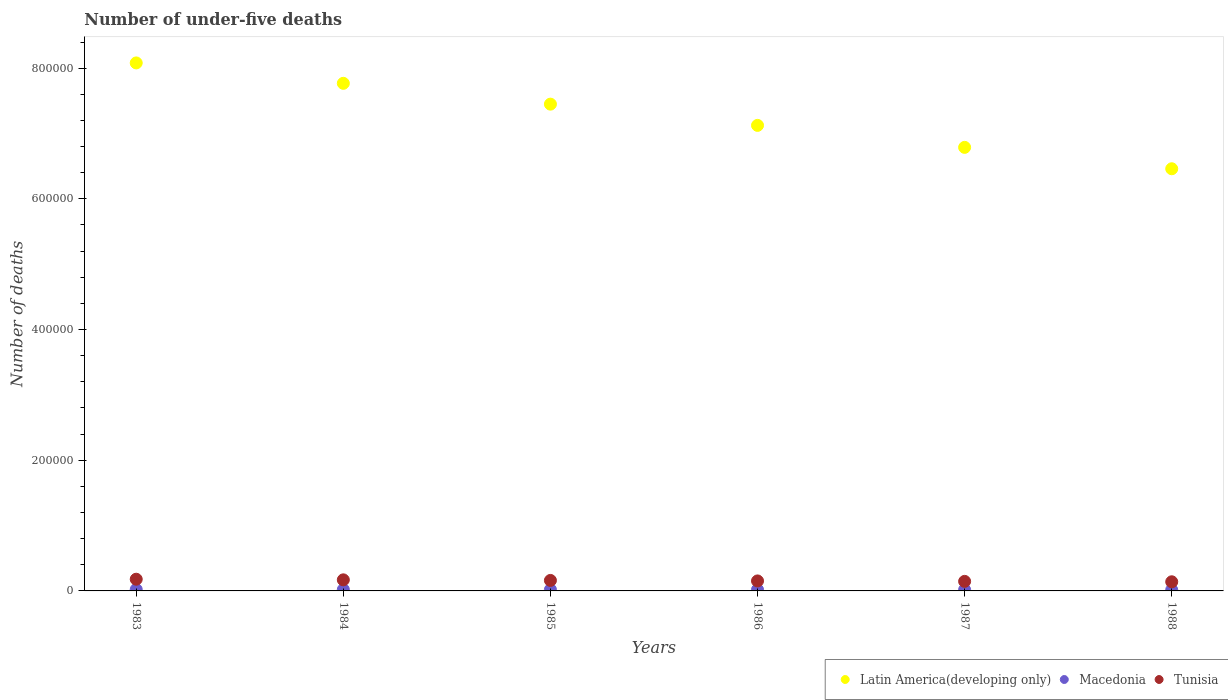Is the number of dotlines equal to the number of legend labels?
Ensure brevity in your answer.  Yes. What is the number of under-five deaths in Latin America(developing only) in 1988?
Offer a very short reply. 6.46e+05. Across all years, what is the maximum number of under-five deaths in Tunisia?
Offer a very short reply. 1.79e+04. Across all years, what is the minimum number of under-five deaths in Latin America(developing only)?
Offer a terse response. 6.46e+05. In which year was the number of under-five deaths in Macedonia maximum?
Your answer should be compact. 1983. What is the total number of under-five deaths in Tunisia in the graph?
Ensure brevity in your answer.  9.48e+04. What is the difference between the number of under-five deaths in Tunisia in 1984 and that in 1988?
Provide a short and direct response. 2978. What is the difference between the number of under-five deaths in Latin America(developing only) in 1984 and the number of under-five deaths in Macedonia in 1988?
Ensure brevity in your answer.  7.75e+05. What is the average number of under-five deaths in Tunisia per year?
Give a very brief answer. 1.58e+04. In the year 1986, what is the difference between the number of under-five deaths in Latin America(developing only) and number of under-five deaths in Macedonia?
Offer a very short reply. 7.11e+05. In how many years, is the number of under-five deaths in Latin America(developing only) greater than 160000?
Make the answer very short. 6. What is the ratio of the number of under-five deaths in Tunisia in 1984 to that in 1987?
Provide a succinct answer. 1.16. What is the difference between the highest and the second highest number of under-five deaths in Latin America(developing only)?
Offer a terse response. 3.12e+04. What is the difference between the highest and the lowest number of under-five deaths in Tunisia?
Offer a very short reply. 3932. Is the sum of the number of under-five deaths in Latin America(developing only) in 1984 and 1988 greater than the maximum number of under-five deaths in Tunisia across all years?
Keep it short and to the point. Yes. Is the number of under-five deaths in Macedonia strictly greater than the number of under-five deaths in Tunisia over the years?
Give a very brief answer. No. How many dotlines are there?
Offer a terse response. 3. How are the legend labels stacked?
Ensure brevity in your answer.  Horizontal. What is the title of the graph?
Make the answer very short. Number of under-five deaths. What is the label or title of the Y-axis?
Offer a very short reply. Number of deaths. What is the Number of deaths of Latin America(developing only) in 1983?
Provide a short and direct response. 8.08e+05. What is the Number of deaths in Macedonia in 1983?
Keep it short and to the point. 2202. What is the Number of deaths of Tunisia in 1983?
Keep it short and to the point. 1.79e+04. What is the Number of deaths of Latin America(developing only) in 1984?
Offer a terse response. 7.77e+05. What is the Number of deaths in Macedonia in 1984?
Your answer should be very brief. 2082. What is the Number of deaths in Tunisia in 1984?
Your answer should be very brief. 1.70e+04. What is the Number of deaths in Latin America(developing only) in 1985?
Ensure brevity in your answer.  7.45e+05. What is the Number of deaths in Macedonia in 1985?
Offer a terse response. 1992. What is the Number of deaths of Tunisia in 1985?
Your answer should be compact. 1.61e+04. What is the Number of deaths in Latin America(developing only) in 1986?
Offer a very short reply. 7.12e+05. What is the Number of deaths of Macedonia in 1986?
Your answer should be compact. 1920. What is the Number of deaths in Tunisia in 1986?
Your answer should be compact. 1.53e+04. What is the Number of deaths of Latin America(developing only) in 1987?
Offer a very short reply. 6.79e+05. What is the Number of deaths in Macedonia in 1987?
Your answer should be very brief. 1805. What is the Number of deaths of Tunisia in 1987?
Provide a succinct answer. 1.46e+04. What is the Number of deaths of Latin America(developing only) in 1988?
Your response must be concise. 6.46e+05. What is the Number of deaths of Macedonia in 1988?
Your response must be concise. 1615. What is the Number of deaths of Tunisia in 1988?
Give a very brief answer. 1.40e+04. Across all years, what is the maximum Number of deaths in Latin America(developing only)?
Provide a short and direct response. 8.08e+05. Across all years, what is the maximum Number of deaths in Macedonia?
Give a very brief answer. 2202. Across all years, what is the maximum Number of deaths of Tunisia?
Ensure brevity in your answer.  1.79e+04. Across all years, what is the minimum Number of deaths of Latin America(developing only)?
Ensure brevity in your answer.  6.46e+05. Across all years, what is the minimum Number of deaths of Macedonia?
Your response must be concise. 1615. Across all years, what is the minimum Number of deaths of Tunisia?
Make the answer very short. 1.40e+04. What is the total Number of deaths of Latin America(developing only) in the graph?
Your answer should be compact. 4.37e+06. What is the total Number of deaths in Macedonia in the graph?
Offer a very short reply. 1.16e+04. What is the total Number of deaths of Tunisia in the graph?
Offer a very short reply. 9.48e+04. What is the difference between the Number of deaths of Latin America(developing only) in 1983 and that in 1984?
Offer a terse response. 3.12e+04. What is the difference between the Number of deaths in Macedonia in 1983 and that in 1984?
Provide a short and direct response. 120. What is the difference between the Number of deaths in Tunisia in 1983 and that in 1984?
Provide a short and direct response. 954. What is the difference between the Number of deaths of Latin America(developing only) in 1983 and that in 1985?
Make the answer very short. 6.31e+04. What is the difference between the Number of deaths in Macedonia in 1983 and that in 1985?
Your answer should be compact. 210. What is the difference between the Number of deaths of Tunisia in 1983 and that in 1985?
Your answer should be very brief. 1849. What is the difference between the Number of deaths of Latin America(developing only) in 1983 and that in 1986?
Your answer should be very brief. 9.56e+04. What is the difference between the Number of deaths of Macedonia in 1983 and that in 1986?
Provide a short and direct response. 282. What is the difference between the Number of deaths in Tunisia in 1983 and that in 1986?
Ensure brevity in your answer.  2610. What is the difference between the Number of deaths of Latin America(developing only) in 1983 and that in 1987?
Keep it short and to the point. 1.29e+05. What is the difference between the Number of deaths in Macedonia in 1983 and that in 1987?
Provide a succinct answer. 397. What is the difference between the Number of deaths in Tunisia in 1983 and that in 1987?
Your response must be concise. 3296. What is the difference between the Number of deaths of Latin America(developing only) in 1983 and that in 1988?
Keep it short and to the point. 1.62e+05. What is the difference between the Number of deaths of Macedonia in 1983 and that in 1988?
Keep it short and to the point. 587. What is the difference between the Number of deaths in Tunisia in 1983 and that in 1988?
Offer a very short reply. 3932. What is the difference between the Number of deaths in Latin America(developing only) in 1984 and that in 1985?
Make the answer very short. 3.19e+04. What is the difference between the Number of deaths in Tunisia in 1984 and that in 1985?
Keep it short and to the point. 895. What is the difference between the Number of deaths of Latin America(developing only) in 1984 and that in 1986?
Provide a short and direct response. 6.44e+04. What is the difference between the Number of deaths of Macedonia in 1984 and that in 1986?
Your answer should be very brief. 162. What is the difference between the Number of deaths in Tunisia in 1984 and that in 1986?
Provide a short and direct response. 1656. What is the difference between the Number of deaths of Latin America(developing only) in 1984 and that in 1987?
Give a very brief answer. 9.80e+04. What is the difference between the Number of deaths in Macedonia in 1984 and that in 1987?
Give a very brief answer. 277. What is the difference between the Number of deaths in Tunisia in 1984 and that in 1987?
Provide a short and direct response. 2342. What is the difference between the Number of deaths of Latin America(developing only) in 1984 and that in 1988?
Offer a very short reply. 1.31e+05. What is the difference between the Number of deaths in Macedonia in 1984 and that in 1988?
Give a very brief answer. 467. What is the difference between the Number of deaths of Tunisia in 1984 and that in 1988?
Provide a succinct answer. 2978. What is the difference between the Number of deaths in Latin America(developing only) in 1985 and that in 1986?
Provide a succinct answer. 3.25e+04. What is the difference between the Number of deaths of Tunisia in 1985 and that in 1986?
Offer a terse response. 761. What is the difference between the Number of deaths in Latin America(developing only) in 1985 and that in 1987?
Make the answer very short. 6.62e+04. What is the difference between the Number of deaths of Macedonia in 1985 and that in 1987?
Your response must be concise. 187. What is the difference between the Number of deaths in Tunisia in 1985 and that in 1987?
Your answer should be compact. 1447. What is the difference between the Number of deaths in Latin America(developing only) in 1985 and that in 1988?
Keep it short and to the point. 9.89e+04. What is the difference between the Number of deaths of Macedonia in 1985 and that in 1988?
Your answer should be very brief. 377. What is the difference between the Number of deaths of Tunisia in 1985 and that in 1988?
Give a very brief answer. 2083. What is the difference between the Number of deaths in Latin America(developing only) in 1986 and that in 1987?
Ensure brevity in your answer.  3.37e+04. What is the difference between the Number of deaths in Macedonia in 1986 and that in 1987?
Give a very brief answer. 115. What is the difference between the Number of deaths in Tunisia in 1986 and that in 1987?
Your answer should be compact. 686. What is the difference between the Number of deaths in Latin America(developing only) in 1986 and that in 1988?
Keep it short and to the point. 6.64e+04. What is the difference between the Number of deaths in Macedonia in 1986 and that in 1988?
Offer a terse response. 305. What is the difference between the Number of deaths in Tunisia in 1986 and that in 1988?
Provide a short and direct response. 1322. What is the difference between the Number of deaths in Latin America(developing only) in 1987 and that in 1988?
Give a very brief answer. 3.27e+04. What is the difference between the Number of deaths of Macedonia in 1987 and that in 1988?
Your response must be concise. 190. What is the difference between the Number of deaths of Tunisia in 1987 and that in 1988?
Make the answer very short. 636. What is the difference between the Number of deaths of Latin America(developing only) in 1983 and the Number of deaths of Macedonia in 1984?
Give a very brief answer. 8.06e+05. What is the difference between the Number of deaths in Latin America(developing only) in 1983 and the Number of deaths in Tunisia in 1984?
Your answer should be very brief. 7.91e+05. What is the difference between the Number of deaths in Macedonia in 1983 and the Number of deaths in Tunisia in 1984?
Provide a short and direct response. -1.48e+04. What is the difference between the Number of deaths in Latin America(developing only) in 1983 and the Number of deaths in Macedonia in 1985?
Provide a succinct answer. 8.06e+05. What is the difference between the Number of deaths of Latin America(developing only) in 1983 and the Number of deaths of Tunisia in 1985?
Your response must be concise. 7.92e+05. What is the difference between the Number of deaths in Macedonia in 1983 and the Number of deaths in Tunisia in 1985?
Offer a very short reply. -1.39e+04. What is the difference between the Number of deaths in Latin America(developing only) in 1983 and the Number of deaths in Macedonia in 1986?
Your response must be concise. 8.06e+05. What is the difference between the Number of deaths of Latin America(developing only) in 1983 and the Number of deaths of Tunisia in 1986?
Give a very brief answer. 7.93e+05. What is the difference between the Number of deaths of Macedonia in 1983 and the Number of deaths of Tunisia in 1986?
Offer a very short reply. -1.31e+04. What is the difference between the Number of deaths in Latin America(developing only) in 1983 and the Number of deaths in Macedonia in 1987?
Offer a very short reply. 8.06e+05. What is the difference between the Number of deaths in Latin America(developing only) in 1983 and the Number of deaths in Tunisia in 1987?
Give a very brief answer. 7.93e+05. What is the difference between the Number of deaths of Macedonia in 1983 and the Number of deaths of Tunisia in 1987?
Your answer should be compact. -1.24e+04. What is the difference between the Number of deaths of Latin America(developing only) in 1983 and the Number of deaths of Macedonia in 1988?
Provide a succinct answer. 8.06e+05. What is the difference between the Number of deaths in Latin America(developing only) in 1983 and the Number of deaths in Tunisia in 1988?
Provide a succinct answer. 7.94e+05. What is the difference between the Number of deaths in Macedonia in 1983 and the Number of deaths in Tunisia in 1988?
Your response must be concise. -1.18e+04. What is the difference between the Number of deaths of Latin America(developing only) in 1984 and the Number of deaths of Macedonia in 1985?
Your answer should be very brief. 7.75e+05. What is the difference between the Number of deaths of Latin America(developing only) in 1984 and the Number of deaths of Tunisia in 1985?
Your response must be concise. 7.61e+05. What is the difference between the Number of deaths of Macedonia in 1984 and the Number of deaths of Tunisia in 1985?
Ensure brevity in your answer.  -1.40e+04. What is the difference between the Number of deaths in Latin America(developing only) in 1984 and the Number of deaths in Macedonia in 1986?
Your answer should be very brief. 7.75e+05. What is the difference between the Number of deaths of Latin America(developing only) in 1984 and the Number of deaths of Tunisia in 1986?
Provide a succinct answer. 7.62e+05. What is the difference between the Number of deaths in Macedonia in 1984 and the Number of deaths in Tunisia in 1986?
Provide a short and direct response. -1.32e+04. What is the difference between the Number of deaths in Latin America(developing only) in 1984 and the Number of deaths in Macedonia in 1987?
Keep it short and to the point. 7.75e+05. What is the difference between the Number of deaths of Latin America(developing only) in 1984 and the Number of deaths of Tunisia in 1987?
Your answer should be compact. 7.62e+05. What is the difference between the Number of deaths of Macedonia in 1984 and the Number of deaths of Tunisia in 1987?
Provide a short and direct response. -1.25e+04. What is the difference between the Number of deaths in Latin America(developing only) in 1984 and the Number of deaths in Macedonia in 1988?
Make the answer very short. 7.75e+05. What is the difference between the Number of deaths in Latin America(developing only) in 1984 and the Number of deaths in Tunisia in 1988?
Provide a short and direct response. 7.63e+05. What is the difference between the Number of deaths of Macedonia in 1984 and the Number of deaths of Tunisia in 1988?
Ensure brevity in your answer.  -1.19e+04. What is the difference between the Number of deaths of Latin America(developing only) in 1985 and the Number of deaths of Macedonia in 1986?
Your response must be concise. 7.43e+05. What is the difference between the Number of deaths in Latin America(developing only) in 1985 and the Number of deaths in Tunisia in 1986?
Give a very brief answer. 7.30e+05. What is the difference between the Number of deaths of Macedonia in 1985 and the Number of deaths of Tunisia in 1986?
Your answer should be compact. -1.33e+04. What is the difference between the Number of deaths of Latin America(developing only) in 1985 and the Number of deaths of Macedonia in 1987?
Provide a short and direct response. 7.43e+05. What is the difference between the Number of deaths in Latin America(developing only) in 1985 and the Number of deaths in Tunisia in 1987?
Make the answer very short. 7.30e+05. What is the difference between the Number of deaths of Macedonia in 1985 and the Number of deaths of Tunisia in 1987?
Offer a terse response. -1.26e+04. What is the difference between the Number of deaths of Latin America(developing only) in 1985 and the Number of deaths of Macedonia in 1988?
Your answer should be compact. 7.43e+05. What is the difference between the Number of deaths in Latin America(developing only) in 1985 and the Number of deaths in Tunisia in 1988?
Your answer should be very brief. 7.31e+05. What is the difference between the Number of deaths in Macedonia in 1985 and the Number of deaths in Tunisia in 1988?
Offer a terse response. -1.20e+04. What is the difference between the Number of deaths of Latin America(developing only) in 1986 and the Number of deaths of Macedonia in 1987?
Make the answer very short. 7.11e+05. What is the difference between the Number of deaths in Latin America(developing only) in 1986 and the Number of deaths in Tunisia in 1987?
Your response must be concise. 6.98e+05. What is the difference between the Number of deaths in Macedonia in 1986 and the Number of deaths in Tunisia in 1987?
Your answer should be compact. -1.27e+04. What is the difference between the Number of deaths of Latin America(developing only) in 1986 and the Number of deaths of Macedonia in 1988?
Your answer should be compact. 7.11e+05. What is the difference between the Number of deaths in Latin America(developing only) in 1986 and the Number of deaths in Tunisia in 1988?
Provide a short and direct response. 6.98e+05. What is the difference between the Number of deaths in Macedonia in 1986 and the Number of deaths in Tunisia in 1988?
Keep it short and to the point. -1.21e+04. What is the difference between the Number of deaths in Latin America(developing only) in 1987 and the Number of deaths in Macedonia in 1988?
Ensure brevity in your answer.  6.77e+05. What is the difference between the Number of deaths of Latin America(developing only) in 1987 and the Number of deaths of Tunisia in 1988?
Ensure brevity in your answer.  6.65e+05. What is the difference between the Number of deaths in Macedonia in 1987 and the Number of deaths in Tunisia in 1988?
Keep it short and to the point. -1.22e+04. What is the average Number of deaths in Latin America(developing only) per year?
Provide a succinct answer. 7.28e+05. What is the average Number of deaths of Macedonia per year?
Keep it short and to the point. 1936. What is the average Number of deaths in Tunisia per year?
Provide a succinct answer. 1.58e+04. In the year 1983, what is the difference between the Number of deaths in Latin America(developing only) and Number of deaths in Macedonia?
Provide a short and direct response. 8.06e+05. In the year 1983, what is the difference between the Number of deaths in Latin America(developing only) and Number of deaths in Tunisia?
Your answer should be very brief. 7.90e+05. In the year 1983, what is the difference between the Number of deaths of Macedonia and Number of deaths of Tunisia?
Offer a terse response. -1.57e+04. In the year 1984, what is the difference between the Number of deaths in Latin America(developing only) and Number of deaths in Macedonia?
Your response must be concise. 7.75e+05. In the year 1984, what is the difference between the Number of deaths of Latin America(developing only) and Number of deaths of Tunisia?
Your response must be concise. 7.60e+05. In the year 1984, what is the difference between the Number of deaths in Macedonia and Number of deaths in Tunisia?
Keep it short and to the point. -1.49e+04. In the year 1985, what is the difference between the Number of deaths of Latin America(developing only) and Number of deaths of Macedonia?
Ensure brevity in your answer.  7.43e+05. In the year 1985, what is the difference between the Number of deaths in Latin America(developing only) and Number of deaths in Tunisia?
Your answer should be very brief. 7.29e+05. In the year 1985, what is the difference between the Number of deaths in Macedonia and Number of deaths in Tunisia?
Make the answer very short. -1.41e+04. In the year 1986, what is the difference between the Number of deaths in Latin America(developing only) and Number of deaths in Macedonia?
Your response must be concise. 7.11e+05. In the year 1986, what is the difference between the Number of deaths of Latin America(developing only) and Number of deaths of Tunisia?
Make the answer very short. 6.97e+05. In the year 1986, what is the difference between the Number of deaths in Macedonia and Number of deaths in Tunisia?
Offer a very short reply. -1.34e+04. In the year 1987, what is the difference between the Number of deaths of Latin America(developing only) and Number of deaths of Macedonia?
Give a very brief answer. 6.77e+05. In the year 1987, what is the difference between the Number of deaths of Latin America(developing only) and Number of deaths of Tunisia?
Give a very brief answer. 6.64e+05. In the year 1987, what is the difference between the Number of deaths of Macedonia and Number of deaths of Tunisia?
Offer a terse response. -1.28e+04. In the year 1988, what is the difference between the Number of deaths of Latin America(developing only) and Number of deaths of Macedonia?
Provide a succinct answer. 6.44e+05. In the year 1988, what is the difference between the Number of deaths of Latin America(developing only) and Number of deaths of Tunisia?
Make the answer very short. 6.32e+05. In the year 1988, what is the difference between the Number of deaths of Macedonia and Number of deaths of Tunisia?
Make the answer very short. -1.24e+04. What is the ratio of the Number of deaths in Latin America(developing only) in 1983 to that in 1984?
Provide a short and direct response. 1.04. What is the ratio of the Number of deaths in Macedonia in 1983 to that in 1984?
Make the answer very short. 1.06. What is the ratio of the Number of deaths in Tunisia in 1983 to that in 1984?
Offer a terse response. 1.06. What is the ratio of the Number of deaths of Latin America(developing only) in 1983 to that in 1985?
Offer a terse response. 1.08. What is the ratio of the Number of deaths in Macedonia in 1983 to that in 1985?
Offer a terse response. 1.11. What is the ratio of the Number of deaths in Tunisia in 1983 to that in 1985?
Provide a succinct answer. 1.12. What is the ratio of the Number of deaths in Latin America(developing only) in 1983 to that in 1986?
Offer a very short reply. 1.13. What is the ratio of the Number of deaths of Macedonia in 1983 to that in 1986?
Keep it short and to the point. 1.15. What is the ratio of the Number of deaths of Tunisia in 1983 to that in 1986?
Offer a very short reply. 1.17. What is the ratio of the Number of deaths in Latin America(developing only) in 1983 to that in 1987?
Offer a terse response. 1.19. What is the ratio of the Number of deaths of Macedonia in 1983 to that in 1987?
Ensure brevity in your answer.  1.22. What is the ratio of the Number of deaths in Tunisia in 1983 to that in 1987?
Give a very brief answer. 1.23. What is the ratio of the Number of deaths of Latin America(developing only) in 1983 to that in 1988?
Ensure brevity in your answer.  1.25. What is the ratio of the Number of deaths in Macedonia in 1983 to that in 1988?
Give a very brief answer. 1.36. What is the ratio of the Number of deaths of Tunisia in 1983 to that in 1988?
Offer a terse response. 1.28. What is the ratio of the Number of deaths in Latin America(developing only) in 1984 to that in 1985?
Provide a short and direct response. 1.04. What is the ratio of the Number of deaths in Macedonia in 1984 to that in 1985?
Offer a terse response. 1.05. What is the ratio of the Number of deaths in Tunisia in 1984 to that in 1985?
Offer a very short reply. 1.06. What is the ratio of the Number of deaths in Latin America(developing only) in 1984 to that in 1986?
Make the answer very short. 1.09. What is the ratio of the Number of deaths of Macedonia in 1984 to that in 1986?
Offer a very short reply. 1.08. What is the ratio of the Number of deaths of Tunisia in 1984 to that in 1986?
Offer a very short reply. 1.11. What is the ratio of the Number of deaths in Latin America(developing only) in 1984 to that in 1987?
Keep it short and to the point. 1.14. What is the ratio of the Number of deaths in Macedonia in 1984 to that in 1987?
Provide a short and direct response. 1.15. What is the ratio of the Number of deaths in Tunisia in 1984 to that in 1987?
Your response must be concise. 1.16. What is the ratio of the Number of deaths in Latin America(developing only) in 1984 to that in 1988?
Provide a succinct answer. 1.2. What is the ratio of the Number of deaths in Macedonia in 1984 to that in 1988?
Provide a succinct answer. 1.29. What is the ratio of the Number of deaths in Tunisia in 1984 to that in 1988?
Your response must be concise. 1.21. What is the ratio of the Number of deaths of Latin America(developing only) in 1985 to that in 1986?
Offer a terse response. 1.05. What is the ratio of the Number of deaths of Macedonia in 1985 to that in 1986?
Make the answer very short. 1.04. What is the ratio of the Number of deaths in Tunisia in 1985 to that in 1986?
Keep it short and to the point. 1.05. What is the ratio of the Number of deaths of Latin America(developing only) in 1985 to that in 1987?
Offer a terse response. 1.1. What is the ratio of the Number of deaths in Macedonia in 1985 to that in 1987?
Provide a short and direct response. 1.1. What is the ratio of the Number of deaths in Tunisia in 1985 to that in 1987?
Keep it short and to the point. 1.1. What is the ratio of the Number of deaths in Latin America(developing only) in 1985 to that in 1988?
Make the answer very short. 1.15. What is the ratio of the Number of deaths in Macedonia in 1985 to that in 1988?
Your answer should be very brief. 1.23. What is the ratio of the Number of deaths in Tunisia in 1985 to that in 1988?
Your response must be concise. 1.15. What is the ratio of the Number of deaths of Latin America(developing only) in 1986 to that in 1987?
Provide a short and direct response. 1.05. What is the ratio of the Number of deaths of Macedonia in 1986 to that in 1987?
Your answer should be very brief. 1.06. What is the ratio of the Number of deaths of Tunisia in 1986 to that in 1987?
Make the answer very short. 1.05. What is the ratio of the Number of deaths of Latin America(developing only) in 1986 to that in 1988?
Make the answer very short. 1.1. What is the ratio of the Number of deaths of Macedonia in 1986 to that in 1988?
Provide a short and direct response. 1.19. What is the ratio of the Number of deaths in Tunisia in 1986 to that in 1988?
Your response must be concise. 1.09. What is the ratio of the Number of deaths of Latin America(developing only) in 1987 to that in 1988?
Offer a very short reply. 1.05. What is the ratio of the Number of deaths in Macedonia in 1987 to that in 1988?
Keep it short and to the point. 1.12. What is the ratio of the Number of deaths in Tunisia in 1987 to that in 1988?
Your answer should be very brief. 1.05. What is the difference between the highest and the second highest Number of deaths of Latin America(developing only)?
Make the answer very short. 3.12e+04. What is the difference between the highest and the second highest Number of deaths in Macedonia?
Provide a succinct answer. 120. What is the difference between the highest and the second highest Number of deaths in Tunisia?
Give a very brief answer. 954. What is the difference between the highest and the lowest Number of deaths in Latin America(developing only)?
Provide a short and direct response. 1.62e+05. What is the difference between the highest and the lowest Number of deaths in Macedonia?
Keep it short and to the point. 587. What is the difference between the highest and the lowest Number of deaths in Tunisia?
Your answer should be very brief. 3932. 